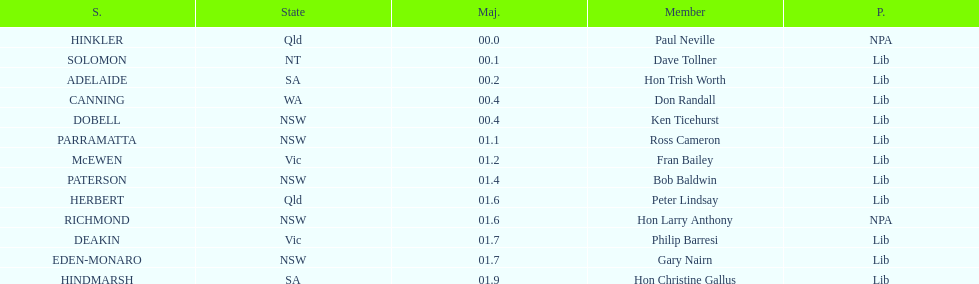Was fran bailey's home state victoria or western australia? Vic. 